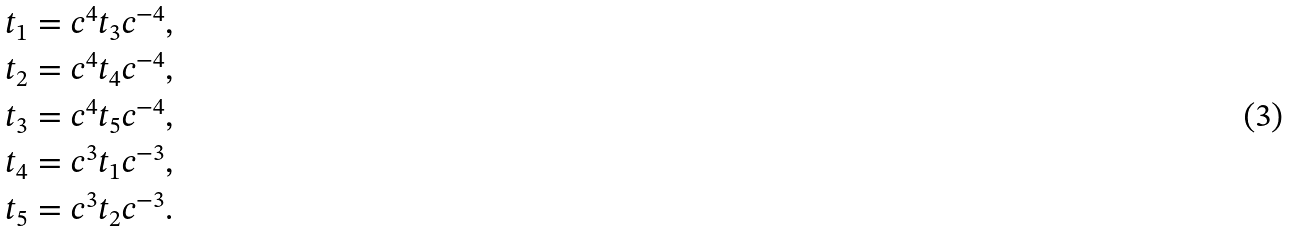<formula> <loc_0><loc_0><loc_500><loc_500>t _ { 1 } & = c ^ { 4 } t _ { 3 } c ^ { - 4 } , \\ t _ { 2 } & = c ^ { 4 } t _ { 4 } c ^ { - 4 } , \\ t _ { 3 } & = c ^ { 4 } t _ { 5 } c ^ { - 4 } , \\ t _ { 4 } & = c ^ { 3 } t _ { 1 } c ^ { - 3 } , \\ t _ { 5 } & = c ^ { 3 } t _ { 2 } c ^ { - 3 } .</formula> 